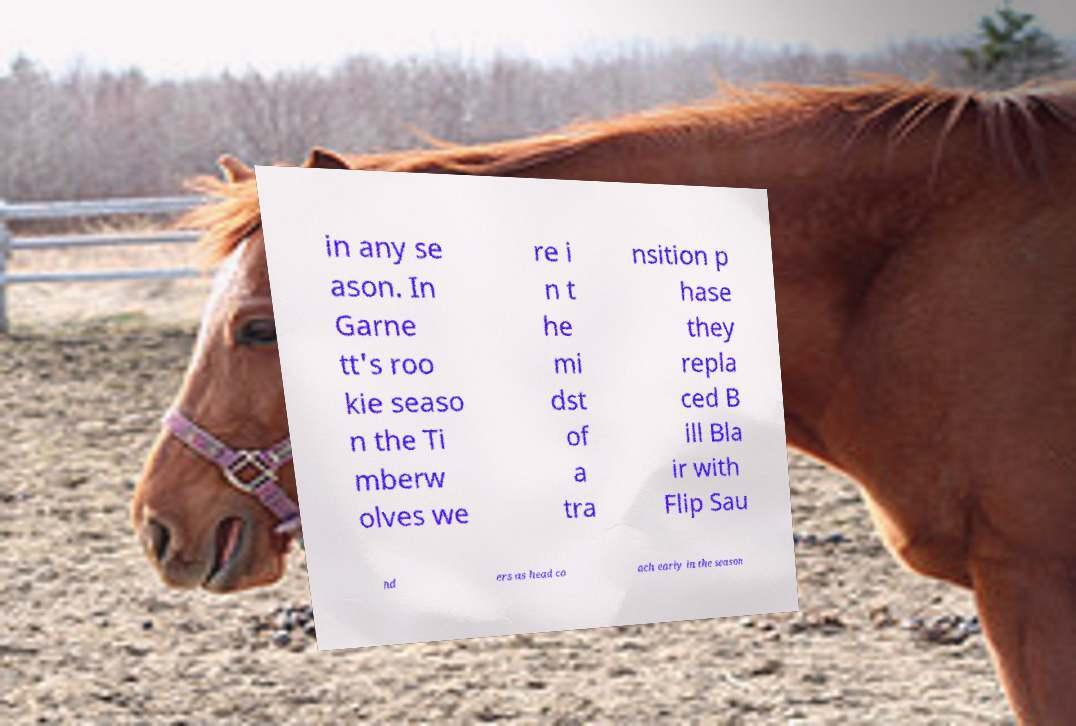For documentation purposes, I need the text within this image transcribed. Could you provide that? in any se ason. In Garne tt's roo kie seaso n the Ti mberw olves we re i n t he mi dst of a tra nsition p hase they repla ced B ill Bla ir with Flip Sau nd ers as head co ach early in the season 